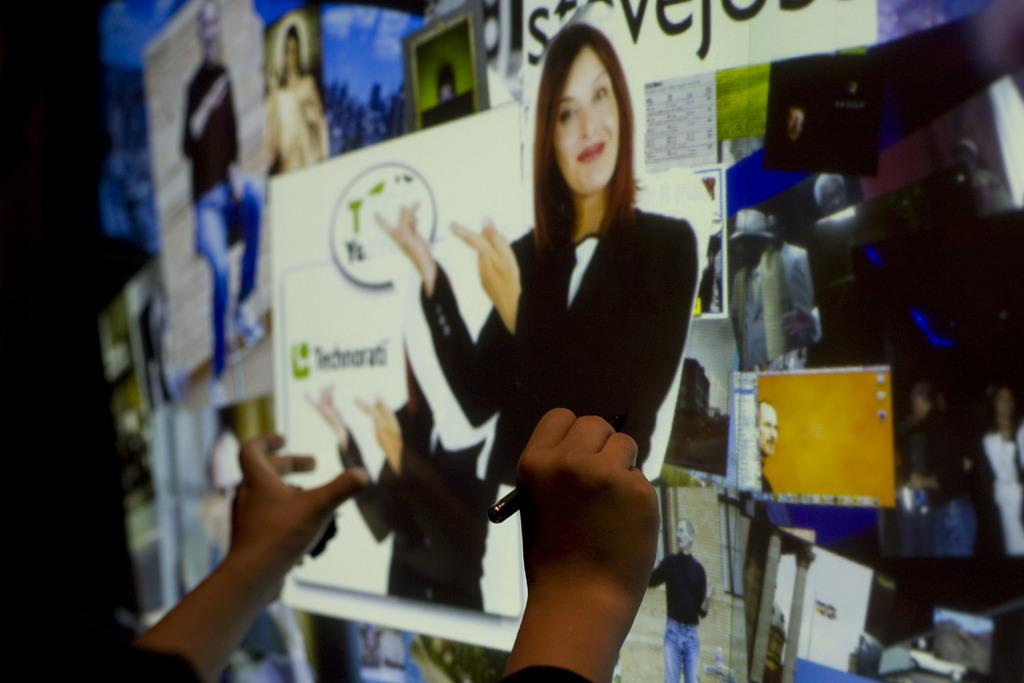What is the main object in the image? There is a projector screen in the image. What is displayed on the projector screen? There are posters on the projector screen. Can you describe the person in the image? There is a person in the image, and they are holding a pen in their hand. Where are the chickens grazing in the image? There are no chickens or grazing fields present in the image. 